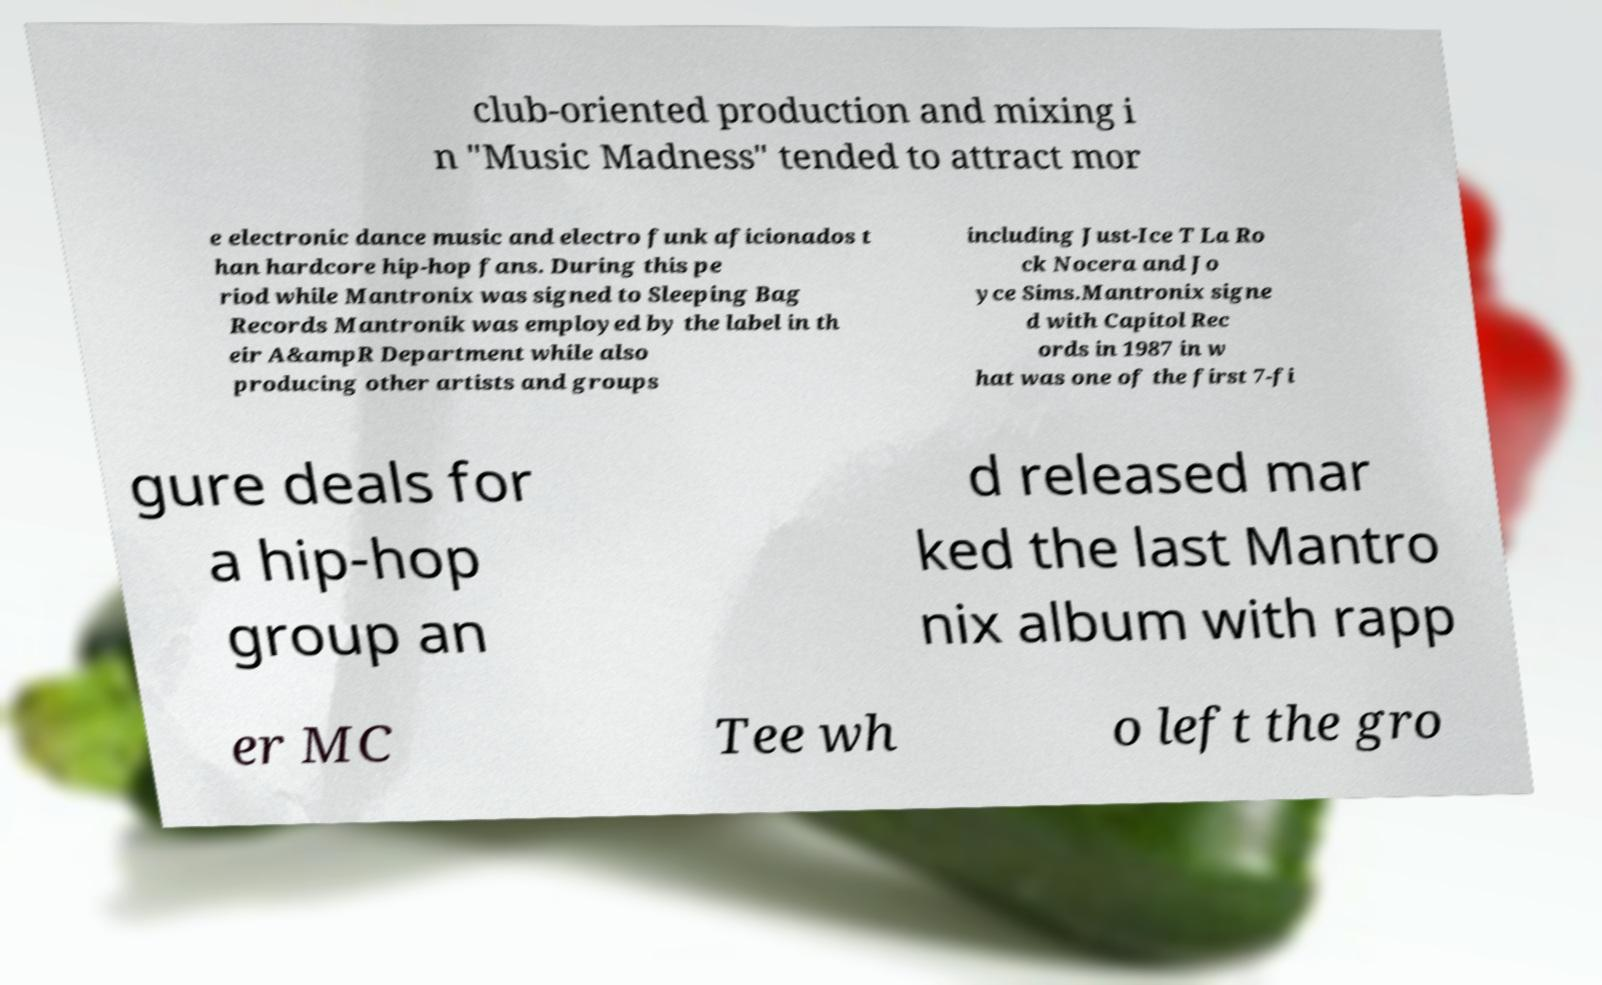There's text embedded in this image that I need extracted. Can you transcribe it verbatim? club-oriented production and mixing i n "Music Madness" tended to attract mor e electronic dance music and electro funk aficionados t han hardcore hip-hop fans. During this pe riod while Mantronix was signed to Sleeping Bag Records Mantronik was employed by the label in th eir A&ampR Department while also producing other artists and groups including Just-Ice T La Ro ck Nocera and Jo yce Sims.Mantronix signe d with Capitol Rec ords in 1987 in w hat was one of the first 7-fi gure deals for a hip-hop group an d released mar ked the last Mantro nix album with rapp er MC Tee wh o left the gro 